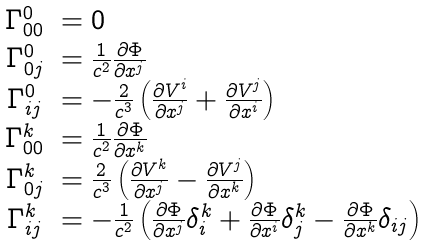<formula> <loc_0><loc_0><loc_500><loc_500>\begin{array} { c l } \Gamma ^ { 0 } _ { 0 0 } & = 0 \\ \Gamma ^ { 0 } _ { 0 j } & = \frac { 1 } { c ^ { 2 } } \frac { \partial \Phi } { \partial x ^ { j } } \\ \Gamma ^ { 0 } _ { i j } & = - \frac { 2 } { c ^ { 3 } } \left ( \frac { \partial V ^ { i } } { \partial x ^ { j } } + \frac { \partial V ^ { j } } { \partial x ^ { i } } \right ) \\ \Gamma ^ { k } _ { 0 0 } & = \frac { 1 } { c ^ { 2 } } \frac { \partial \Phi } { \partial x ^ { k } } \\ \Gamma ^ { k } _ { 0 j } & = \frac { 2 } { c ^ { 3 } } \left ( \frac { \partial V ^ { k } } { \partial x ^ { j } } - \frac { \partial V ^ { j } } { \partial x ^ { k } } \right ) \\ \Gamma ^ { k } _ { i j } & = - \frac { 1 } { c ^ { 2 } } \left ( \frac { \partial \Phi } { \partial x ^ { j } } \delta ^ { k } _ { i } + \frac { \partial \Phi } { \partial x ^ { i } } \delta ^ { k } _ { j } - \frac { \partial \Phi } { \partial x ^ { k } } \delta _ { i j } \right ) \end{array}</formula> 